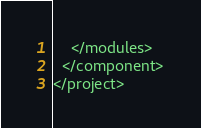<code> <loc_0><loc_0><loc_500><loc_500><_XML_>    </modules>
  </component>
</project></code> 